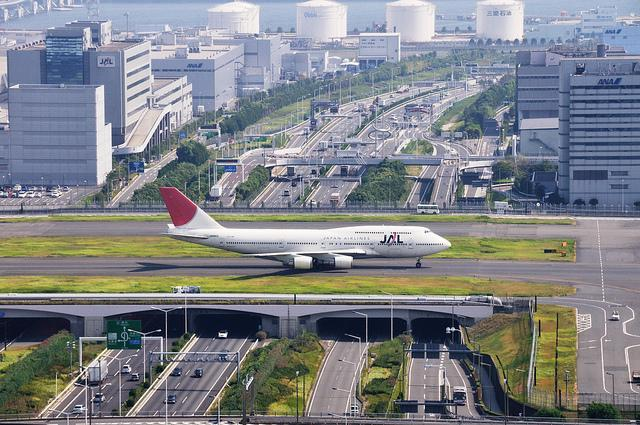What is the large vehicle getting ready to do? Please explain your reasoning. fly. This is an airliner 